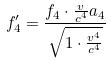Convert formula to latex. <formula><loc_0><loc_0><loc_500><loc_500>f _ { 4 } ^ { \prime } = \frac { f _ { 4 } \cdot \frac { v } { c ^ { 4 } } a _ { 4 } } { \sqrt { 1 \cdot \frac { v ^ { 4 } } { c ^ { 4 } } } }</formula> 